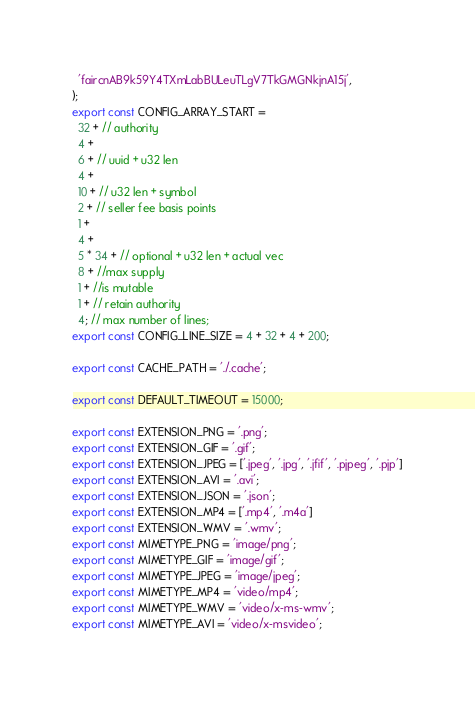<code> <loc_0><loc_0><loc_500><loc_500><_TypeScript_>  'faircnAB9k59Y4TXmLabBULeuTLgV7TkGMGNkjnA15j',
);
export const CONFIG_ARRAY_START =
  32 + // authority
  4 +
  6 + // uuid + u32 len
  4 +
  10 + // u32 len + symbol
  2 + // seller fee basis points
  1 +
  4 +
  5 * 34 + // optional + u32 len + actual vec
  8 + //max supply
  1 + //is mutable
  1 + // retain authority
  4; // max number of lines;
export const CONFIG_LINE_SIZE = 4 + 32 + 4 + 200;

export const CACHE_PATH = './.cache';

export const DEFAULT_TIMEOUT = 15000;

export const EXTENSION_PNG = '.png';
export const EXTENSION_GIF = '.gif';
export const EXTENSION_JPEG = ['.jpeg', '.jpg', '.jfif', '.pjpeg', '.pjp']
export const EXTENSION_AVI = '.avi';
export const EXTENSION_JSON = '.json';
export const EXTENSION_MP4 = ['.mp4', '.m4a']
export const EXTENSION_WMV = '.wmv';
export const MIMETYPE_PNG = 'image/png';
export const MIMETYPE_GIF = 'image/gif';
export const MIMETYPE_JPEG = 'image/jpeg';
export const MIMETYPE_MP4 = 'video/mp4';
export const MIMETYPE_WMV = 'video/x-ms-wmv';
export const MIMETYPE_AVI = 'video/x-msvideo';
</code> 